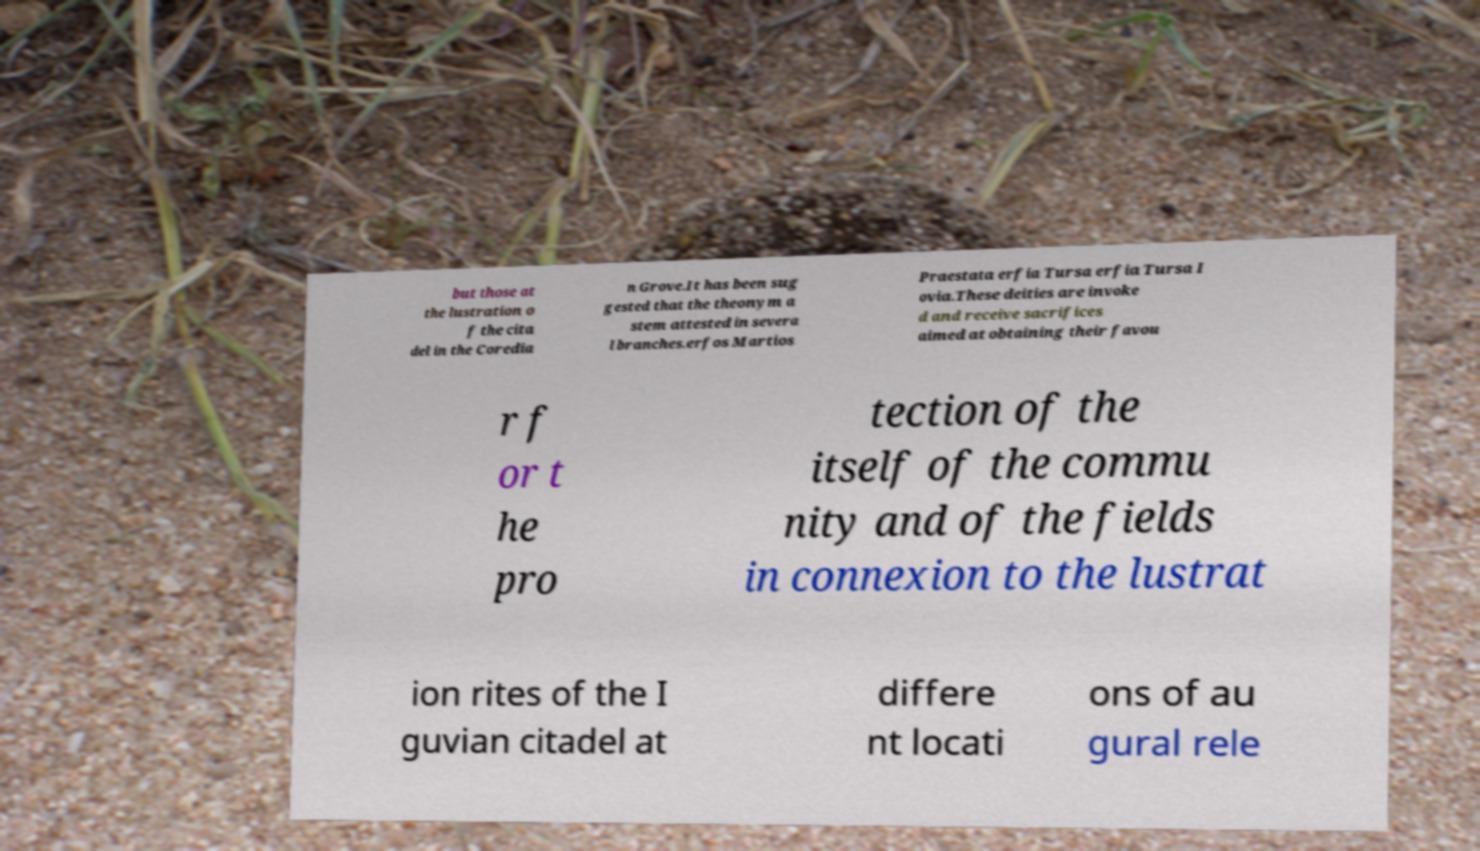What messages or text are displayed in this image? I need them in a readable, typed format. but those at the lustration o f the cita del in the Coredia n Grove.It has been sug gested that the theonym a stem attested in severa l branches.erfos Martios Praestata erfia Tursa erfia Tursa I ovia.These deities are invoke d and receive sacrifices aimed at obtaining their favou r f or t he pro tection of the itself of the commu nity and of the fields in connexion to the lustrat ion rites of the I guvian citadel at differe nt locati ons of au gural rele 